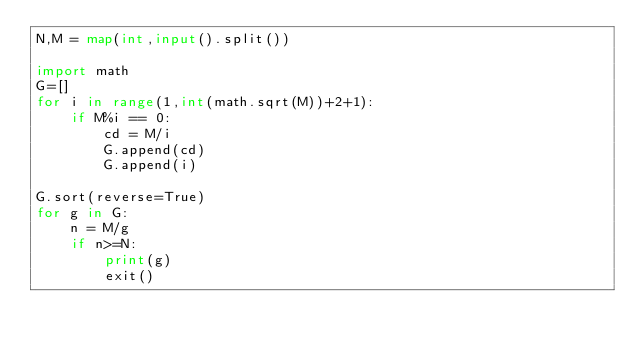<code> <loc_0><loc_0><loc_500><loc_500><_Python_>N,M = map(int,input().split())

import math
G=[]
for i in range(1,int(math.sqrt(M))+2+1):
    if M%i == 0:
        cd = M/i
        G.append(cd)
        G.append(i)

G.sort(reverse=True)
for g in G:
    n = M/g
    if n>=N:
        print(g)
        exit()







</code> 